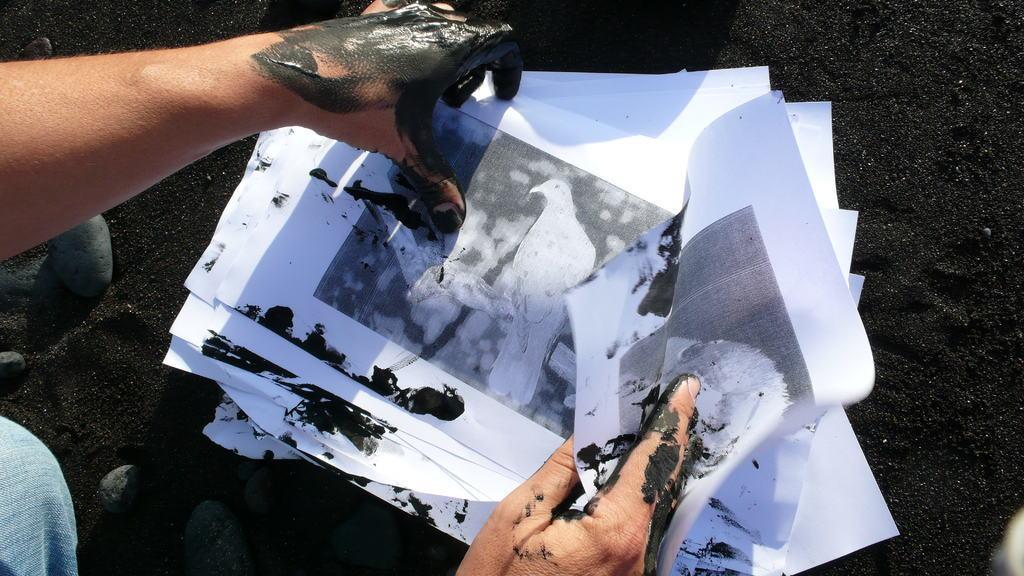Could you give a brief overview of what you see in this image? In the center of the image we can see one person holding papers. And we can see some black paint on the hands. In the background we can see stones and black soil. 